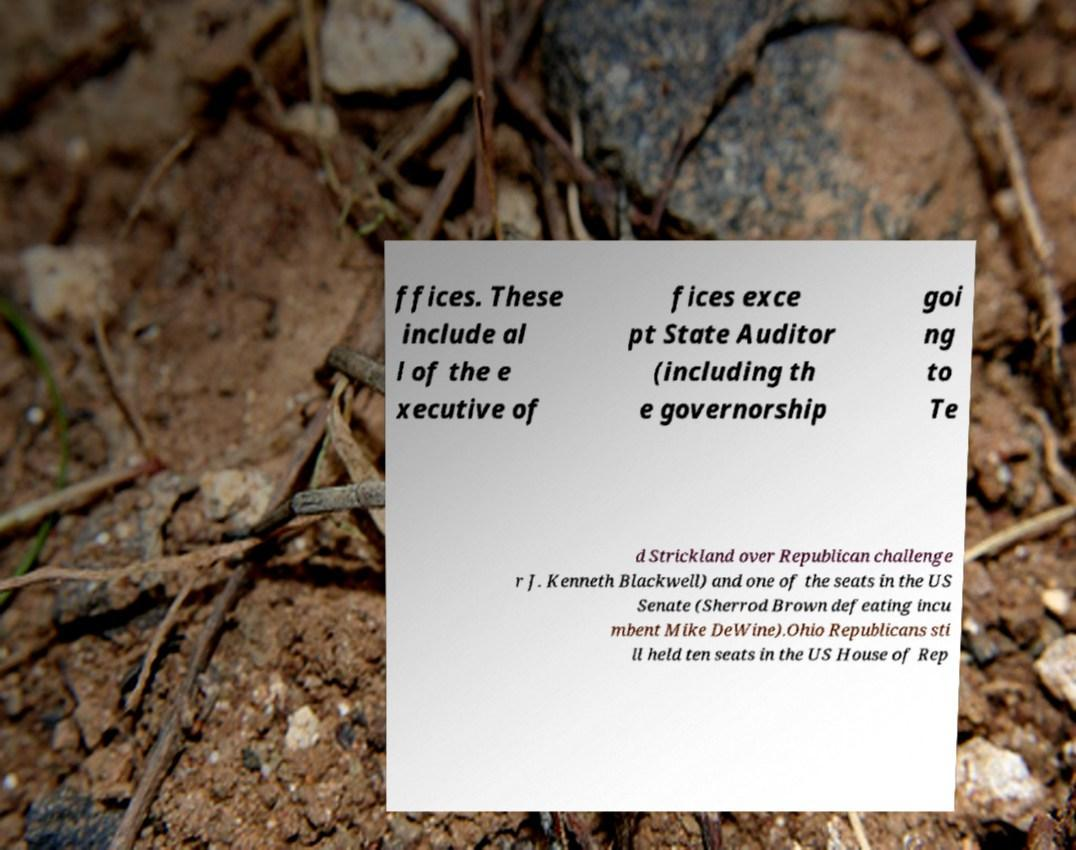What messages or text are displayed in this image? I need them in a readable, typed format. ffices. These include al l of the e xecutive of fices exce pt State Auditor (including th e governorship goi ng to Te d Strickland over Republican challenge r J. Kenneth Blackwell) and one of the seats in the US Senate (Sherrod Brown defeating incu mbent Mike DeWine).Ohio Republicans sti ll held ten seats in the US House of Rep 